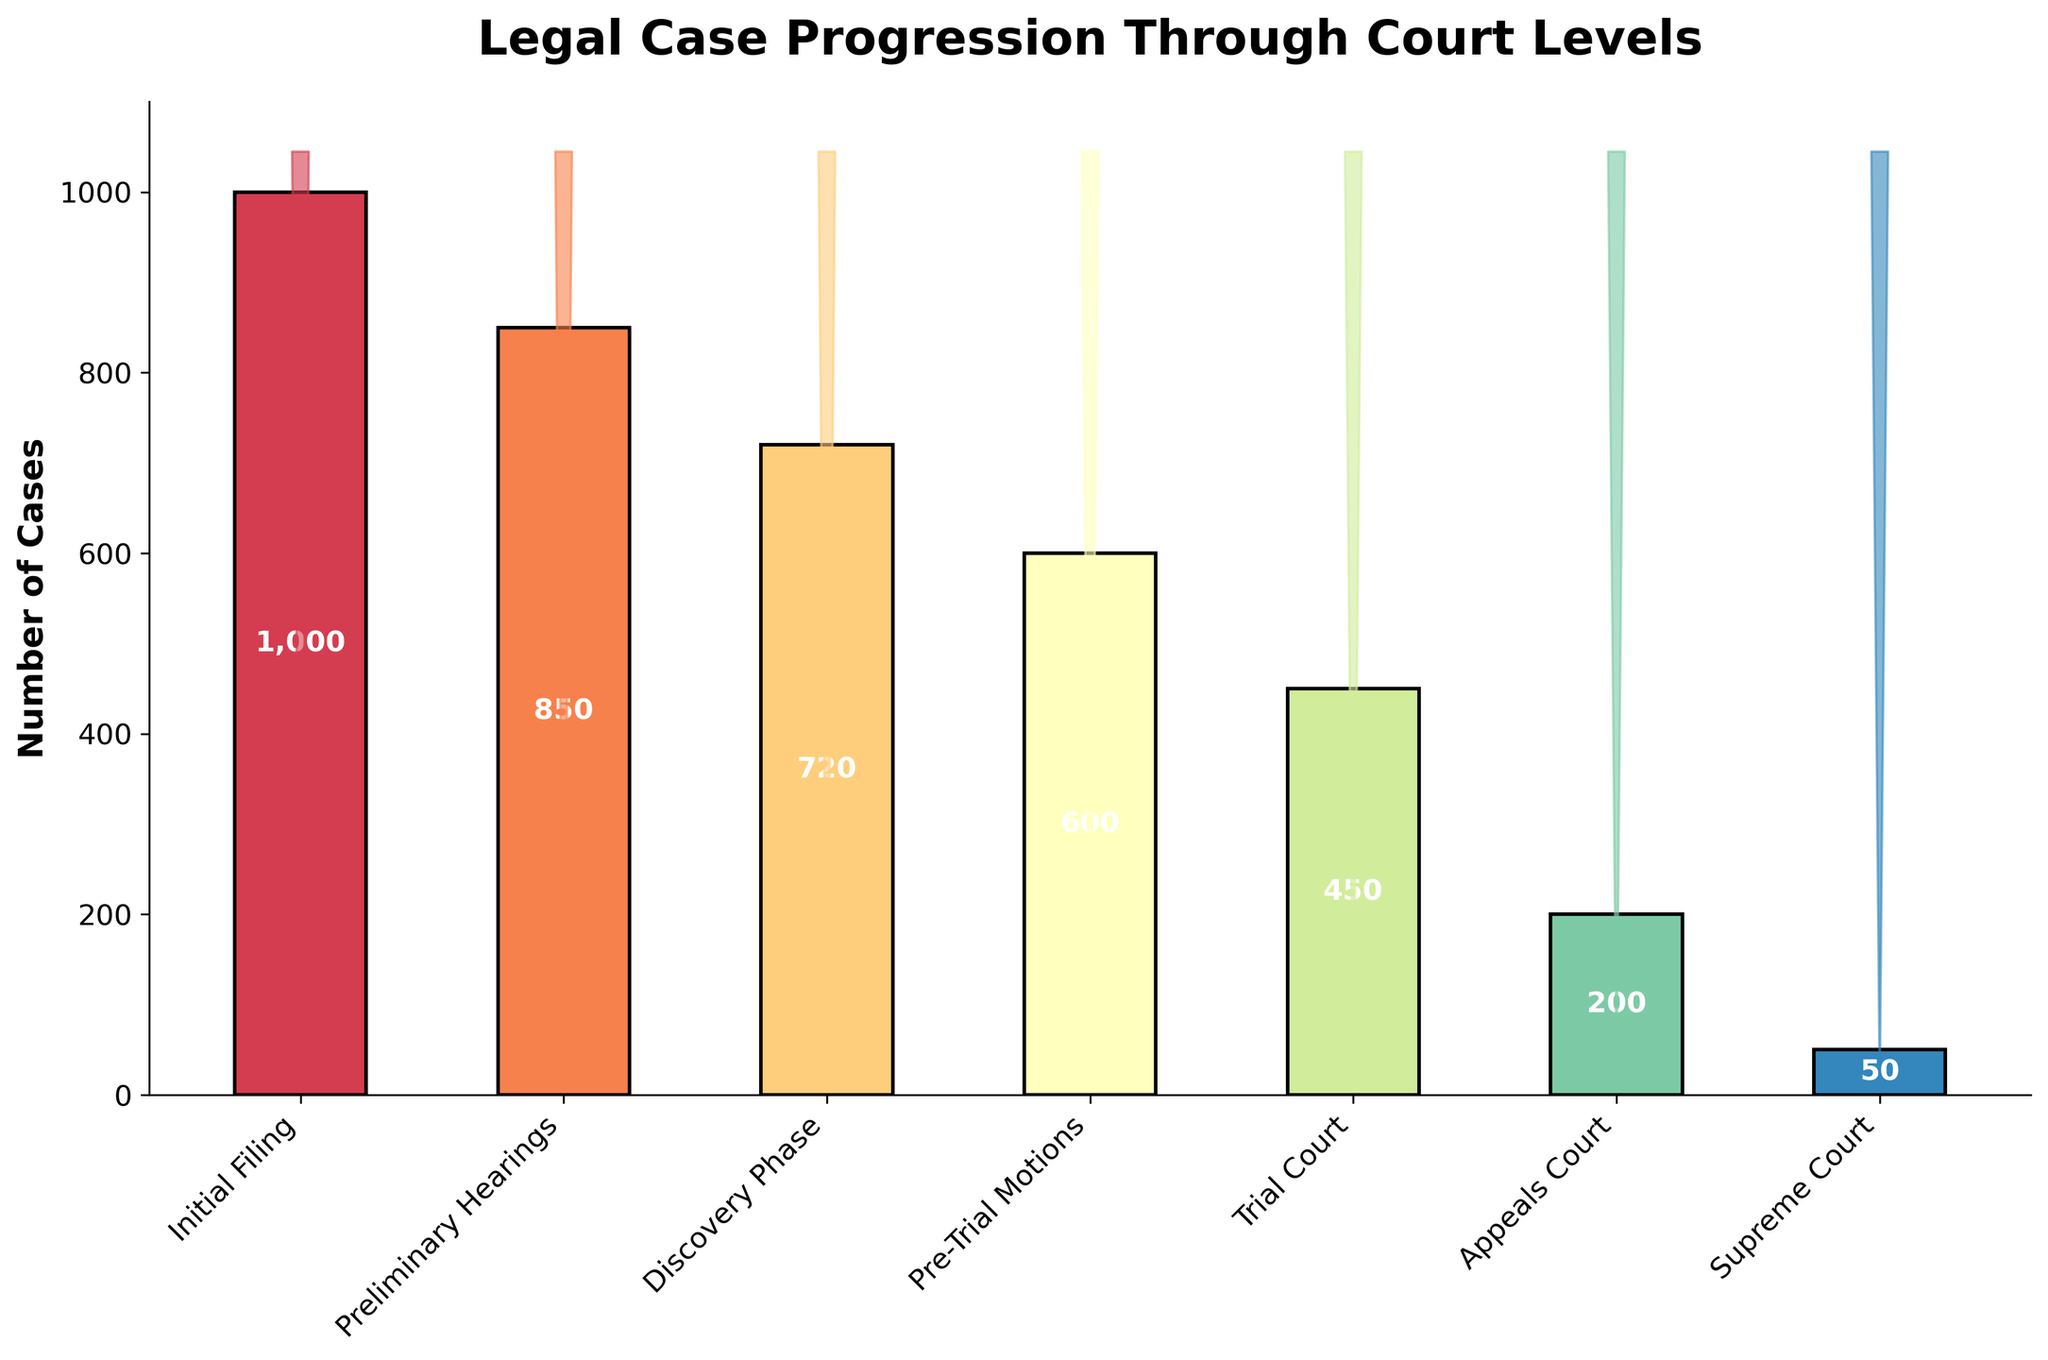What is the title of the funnel chart? The title is usually displayed at the top of the chart, and it summarizes the main topic or purpose of the visual. In this case, we see "Legal Case Progression Through Court Levels" at the top.
Answer: Legal Case Progression Through Court Levels How many case progression stages are displayed in the chart? Count the distinct bars or labels along the x-axis, which represent the different stages of the legal case progression. In the chart, we see seven stages listed.
Answer: Seven Which stage has the highest number of cases? Look for the tallest bar in the chart, which represents the stage with the highest number of cases. The initial stage, "Initial Filing," has the tallest bar.
Answer: Initial Filing What is the number of cases at the Supreme Court stage? Observe the bar corresponding to the "Supreme Court" stage and read the number inside or above the bar. The label indicates there are 50 cases at this stage.
Answer: 50 How many cases are lost between the Discovery Phase and the Appeals Court stage? Subtract the number of cases at the Appeals Court stage from the number of cases at the Discovery Phase stage. There are 720 cases in the Discovery Phase and 200 in the Appeals Court. Therefore, 720 - 200 = 520 cases are lost.
Answer: 520 What percentage of cases from Initial Filing reach the Supreme Court? Calculate the percentage by dividing the number of cases reaching the Supreme Court by the number of cases at the Initial Filing stage and then multiplying by 100. This is calculated as (50 / 1000) * 100 = 5%.
Answer: 5% What is the average number of cases per stage? Sum the number of cases at all stages and divide by the number of stages. The total is 1000 + 850 + 720 + 600 + 450 + 200 + 50 = 3870. Dividing by 7 stages gives 3870 / 7 ≈ 552.86.
Answer: 552.86 Between which two stages is there an increase in the number of cases? Examine the heights of consecutive bars to identify any stage where the later stage's bar is taller than the preceding stage's. In this chart, all stages show a decrease, and no stage has an increase in the number of cases.
Answer: None 